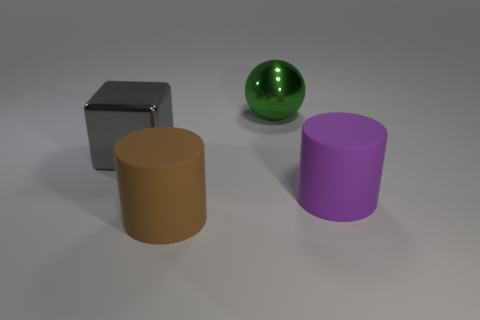Add 2 brown metal balls. How many objects exist? 6 Subtract all purple cylinders. How many cylinders are left? 1 Subtract 1 balls. How many balls are left? 0 Add 2 large metal cubes. How many large metal cubes exist? 3 Subtract 0 yellow cylinders. How many objects are left? 4 Subtract all blocks. How many objects are left? 3 Subtract all brown cubes. Subtract all green cylinders. How many cubes are left? 1 Subtract all purple cubes. How many brown cylinders are left? 1 Subtract all large gray things. Subtract all big purple matte cylinders. How many objects are left? 2 Add 4 big metal cubes. How many big metal cubes are left? 5 